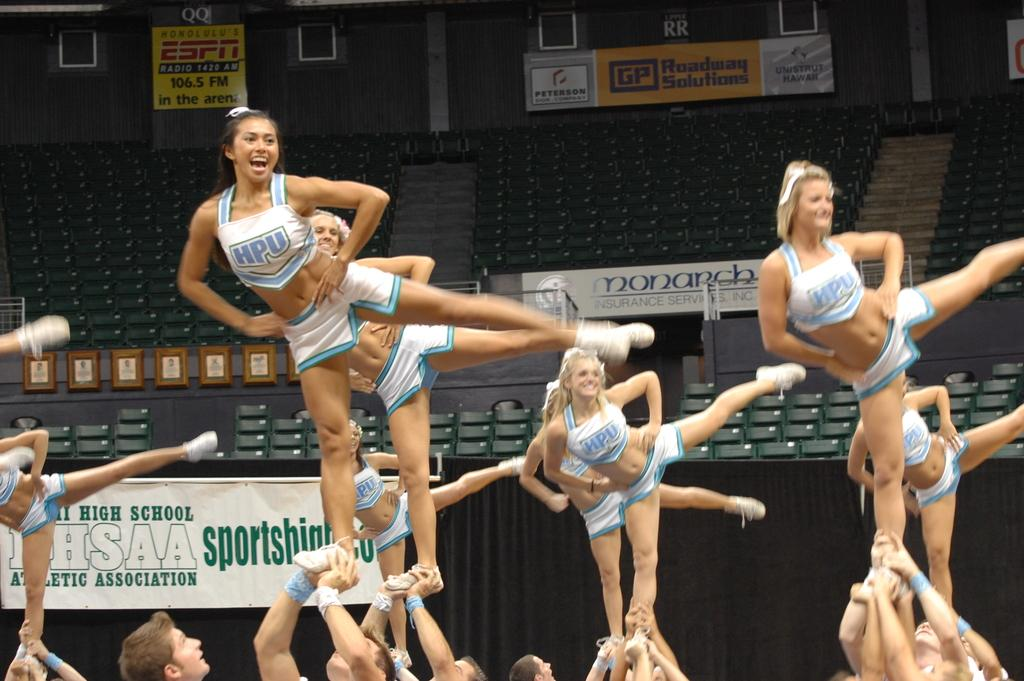<image>
Render a clear and concise summary of the photo. A group of cheerleaders from HPU are doing a routine. 